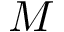<formula> <loc_0><loc_0><loc_500><loc_500>M</formula> 